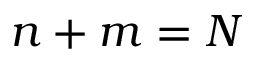<formula> <loc_0><loc_0><loc_500><loc_500>n + m = N</formula> 